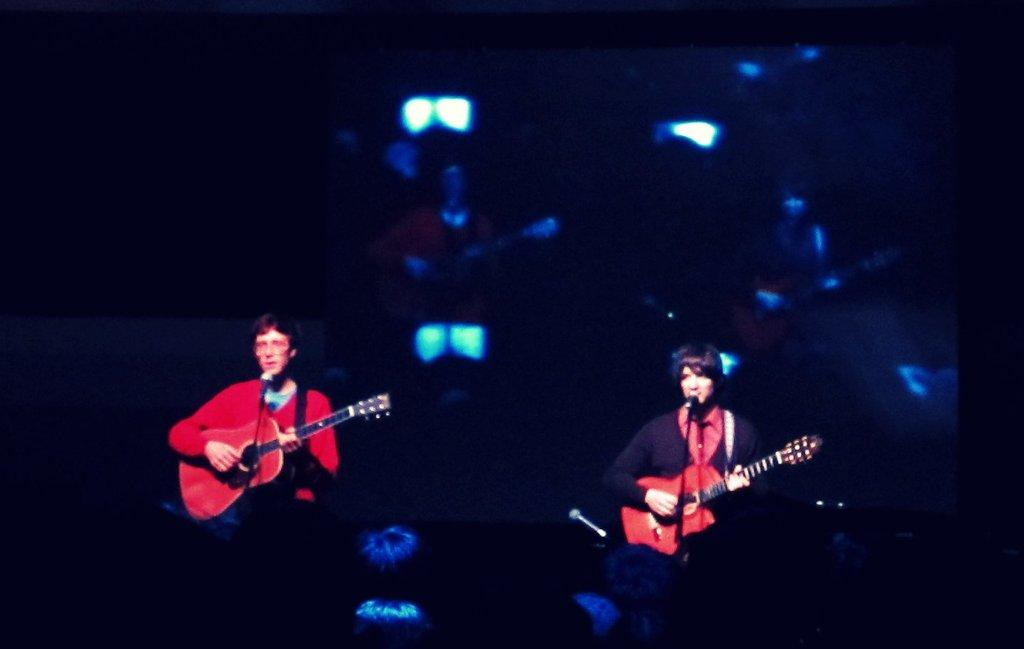How many people are in the image? There are two persons in the image. What are the two persons doing? The two persons are standing and playing guitars. What can be seen in the background of the image? There is a screen in the background of the image. What else is visible in the image? There are lights visible in the image. What type of holiday is being celebrated in the image? There is no indication of a holiday being celebrated in the image. What activity is the hose being used for in the image? There is no hose present in the image. 